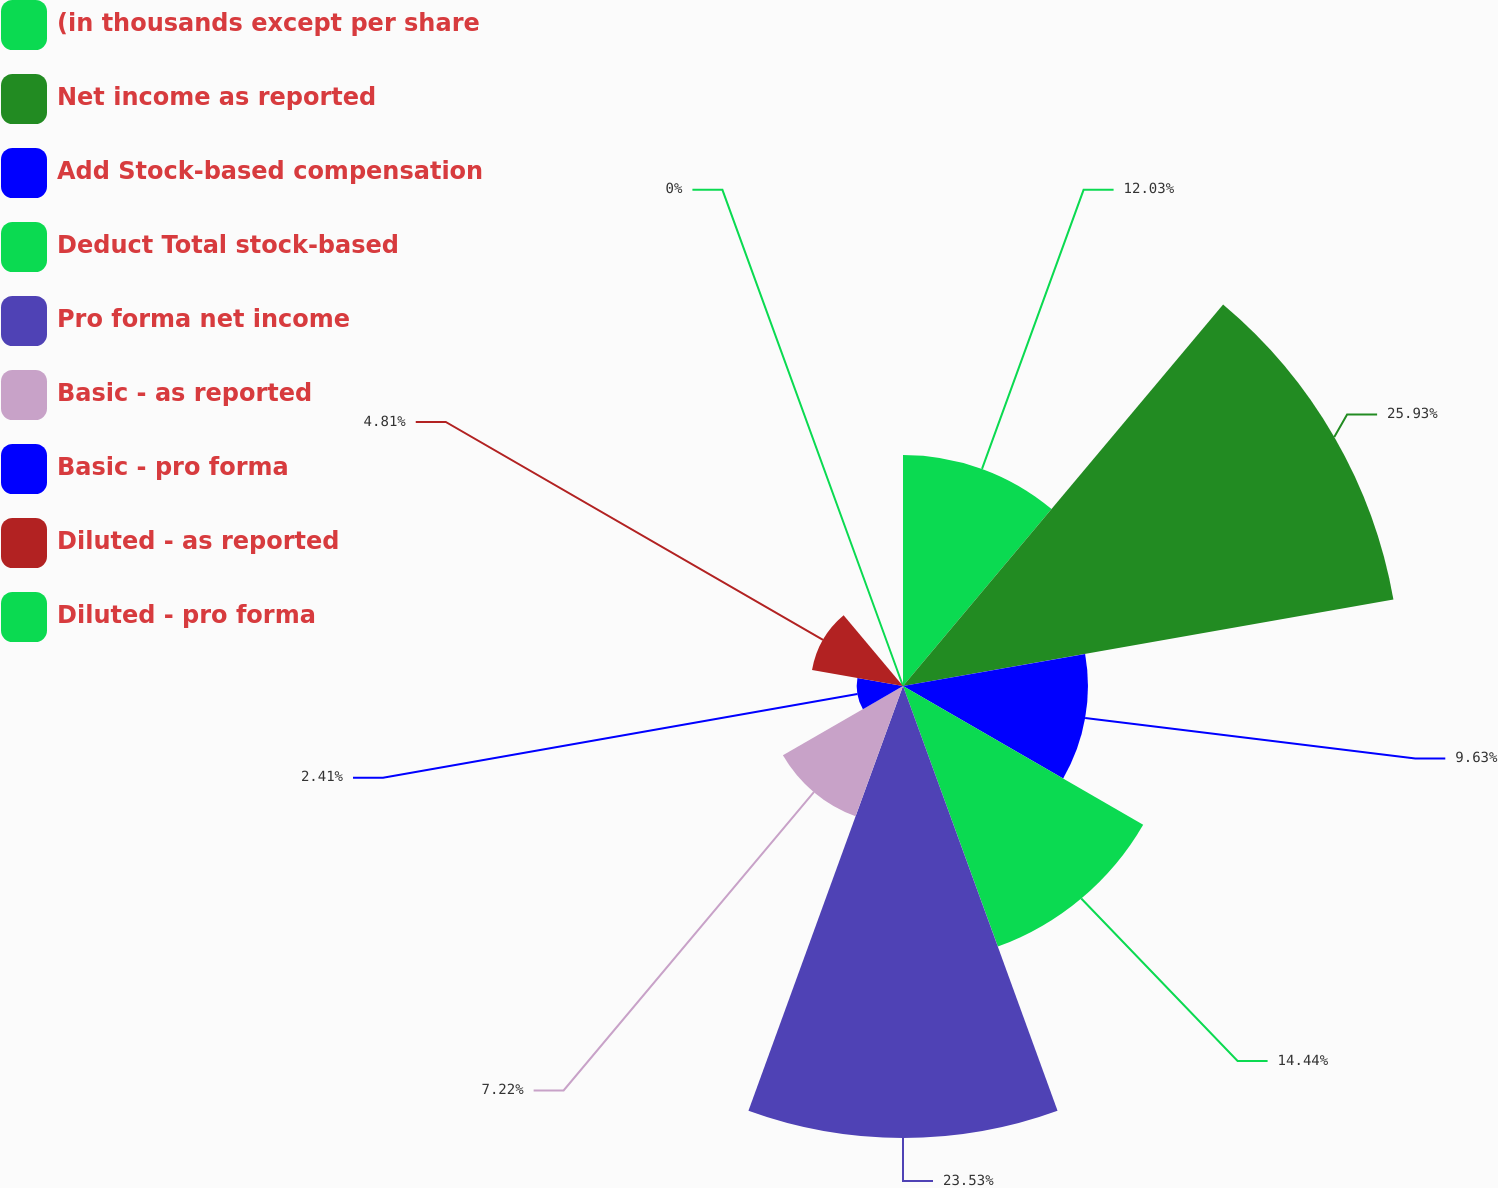<chart> <loc_0><loc_0><loc_500><loc_500><pie_chart><fcel>(in thousands except per share<fcel>Net income as reported<fcel>Add Stock-based compensation<fcel>Deduct Total stock-based<fcel>Pro forma net income<fcel>Basic - as reported<fcel>Basic - pro forma<fcel>Diluted - as reported<fcel>Diluted - pro forma<nl><fcel>12.03%<fcel>25.93%<fcel>9.63%<fcel>14.44%<fcel>23.53%<fcel>7.22%<fcel>2.41%<fcel>4.81%<fcel>0.0%<nl></chart> 